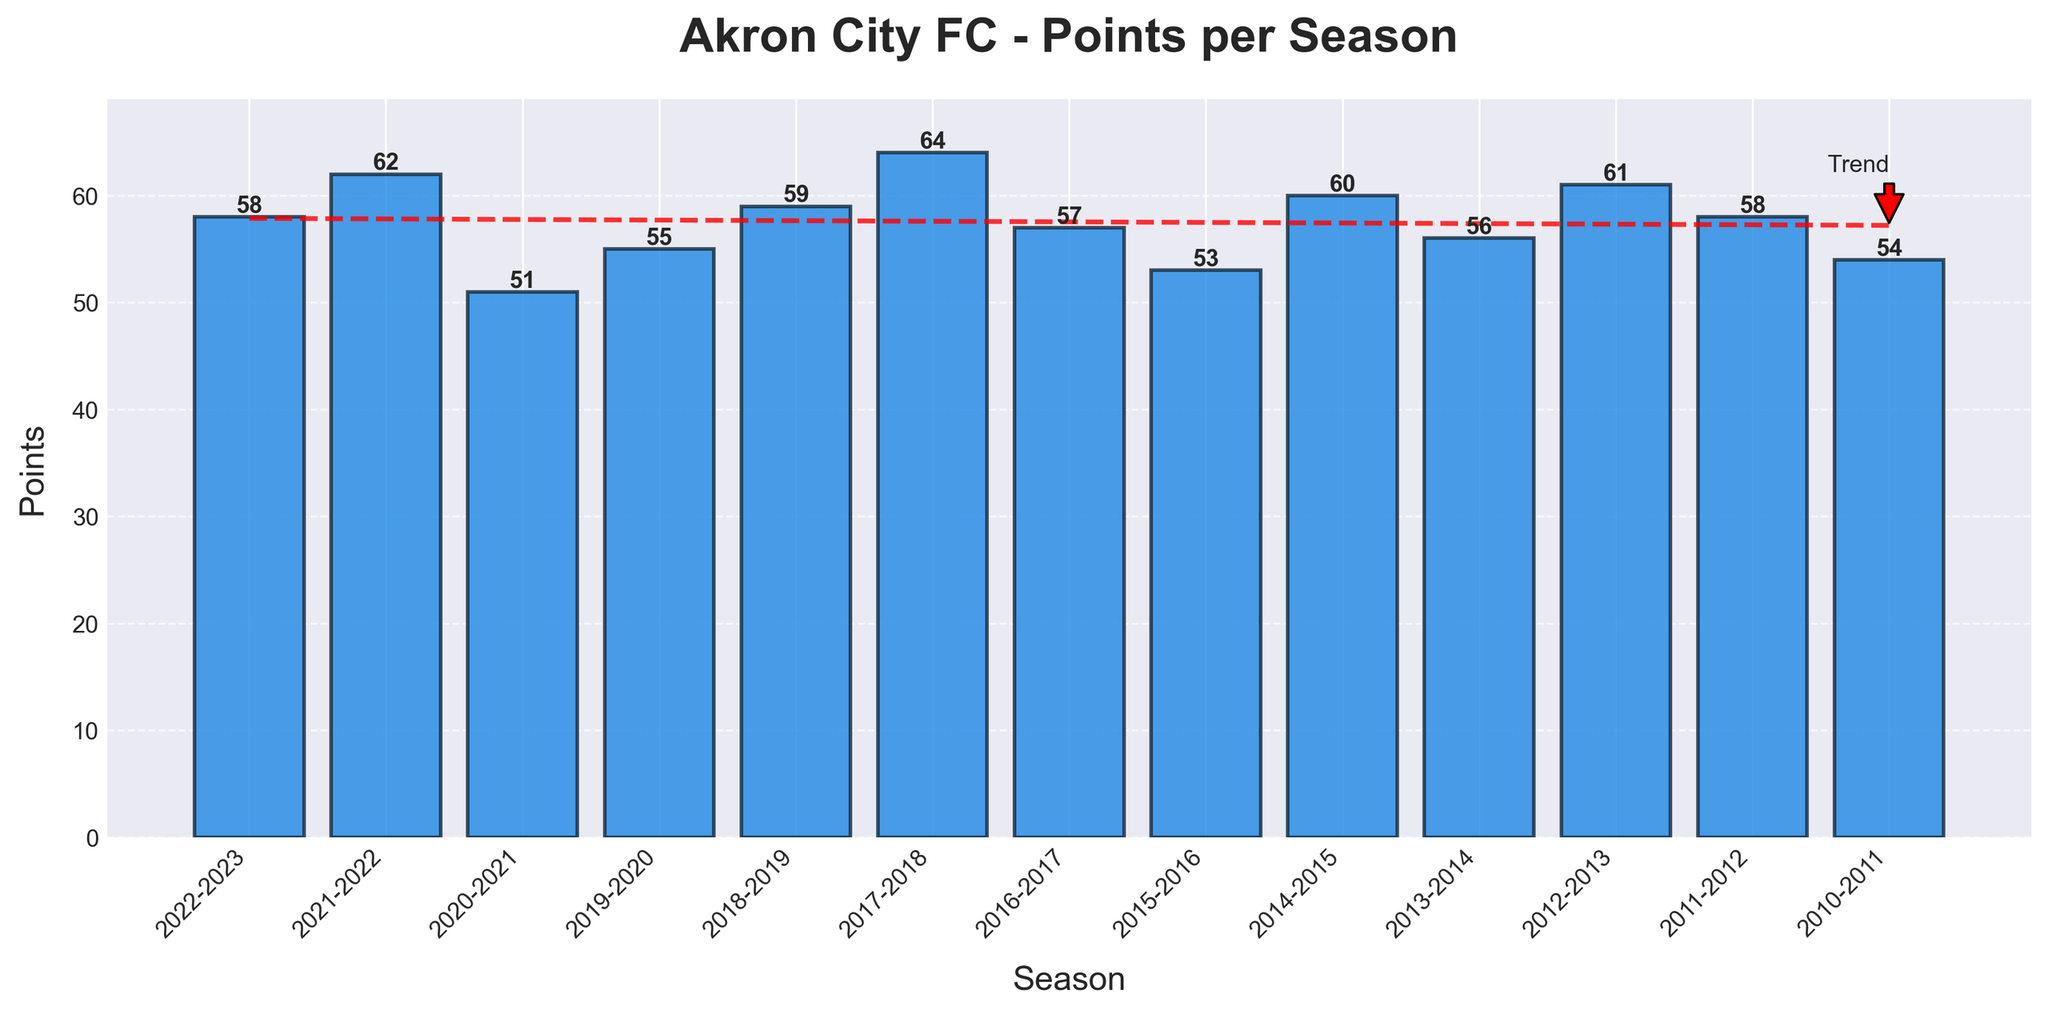What is the highest number of points Akron City FC earned in a single season? Look for the tallest bar in the chart to determine the season with the highest number of points. The highest bar represents the 2017-2018 season with 64 points.
Answer: 64 points What is the lowest number of points Akron City FC earned in a single season? Look for the shortest bar in the chart to identify the season with the lowest number of points. The lowest bar represents the 2020-2021 season with 51 points.
Answer: 51 points How many seasons did Akron City FC earn more than 60 points? Count the number of bars that reach above the 60-point mark. There are four bars: 2011-2012 (61 points), 2014-2015 (60 points), 2017-2018 (64 points), 2021-2022 (62 points).
Answer: 4 seasons In which seasons did Akron City FC earn exactly 58 points? Look for bars labeled with a value of 58. There are two such bars: 2011-2012 and 2022-2023.
Answer: 2011-2012 and 2022-2023 What is the average number of points Akron City FC earned over the last 10 seasons? Sum up the points for each season displayed (58 + 62 + 51 + 55 + 59 + 64 + 57 + 53 + 60 + 56) and divide by the number of seasons, which is 10. The average is (58 + 62 + 51 + 55 + 59 + 64 + 57 + 53 + 60 + 56) / 10 = 57.5.
Answer: 57.5 points Which season had a higher point total: 2015-2016 or 2018-2019? Compare the heights of the bars for the 2015-2016 and 2018-2019 seasons. 2018-2019 had 59 points and 2015-2016 had 53 points.
Answer: 2018-2019 What is the trend in points over the last 10 seasons? Observe the direction of the trend line annotated on the chart. The trend line indicates a generally increasing trend over the last 10 seasons.
Answer: Increasing trend What is the difference in points between the 2021-2022 and 2022-2023 seasons? Subtract the number of points earned in the 2022-2023 season from the points in the 2021-2022 season (62 - 58). The difference is 4 points.
Answer: 4 points How many more points did Akron City FC earn in the 2017-2018 season compared to the 2010-2011 season? Subtract the points in the 2010-2011 season from the points in the 2017-2018 season (64 - 54). The difference is 10 points.
Answer: 10 points Which seasons are above the overall average points of the last 10 seasons? First calculate the average points over the 10 seasons: (58 + 62 + 51 + 55 + 59 + 64 + 57 + 53 + 60 + 56) / 10 = 57.5. Then identify the seasons with points above this average: 2021-2022 (62), 2018-2019 (59), 2017-2018 (64), 2014-2015 (60), and 2012-2013 (61).
Answer: 2021-2022, 2018-2019, 2017-2018, 2014-2015, 2012-2013 